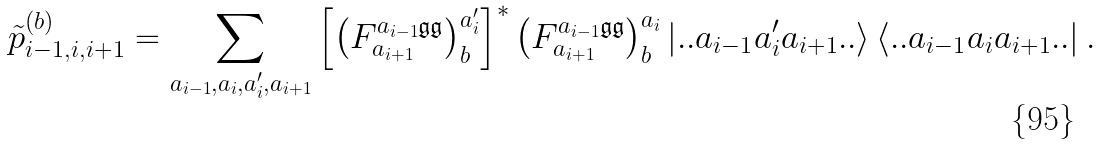<formula> <loc_0><loc_0><loc_500><loc_500>\tilde { p } ^ { ( b ) } _ { i - 1 , i , i + 1 } = \sum _ { a _ { i - 1 } , a _ { i } , a _ { i } ^ { \prime } , a _ { i + 1 } } \left [ \left ( F ^ { a _ { i - 1 } \mathfrak { g } \mathfrak { g } } _ { a _ { i + 1 } } \right ) ^ { a _ { i } ^ { \prime } } _ { b } \right ] ^ { * } \left ( F ^ { a _ { i - 1 } \mathfrak { g } \mathfrak { g } } _ { a _ { i + 1 } } \right ) ^ { a _ { i } } _ { b } \left | . . a _ { i - 1 } a _ { i } ^ { \prime } a _ { i + 1 } . . \right > \left < . . a _ { i - 1 } a _ { i } a _ { i + 1 } . . \right | .</formula> 